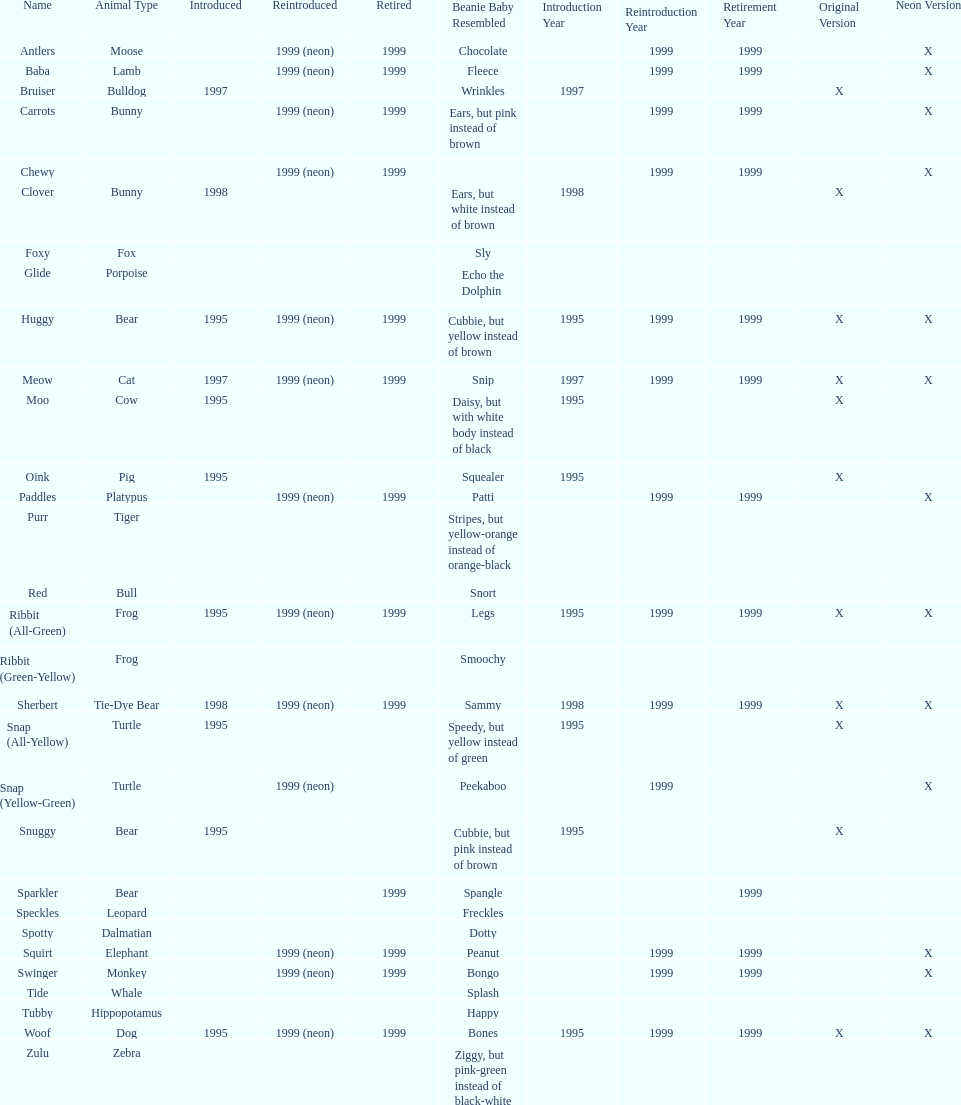How many total pillow pals were both reintroduced and retired in 1999? 12. 